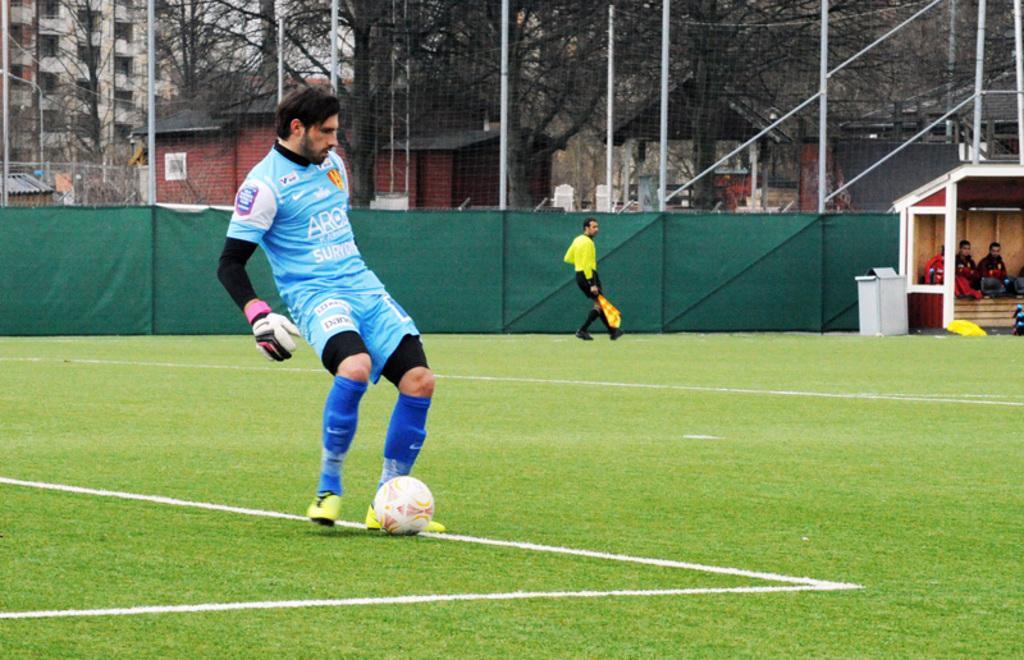In one or two sentences, can you explain what this image depicts? In this image I can see an open grass ground and on it I can see two persons are standing. I can see both of them are wearing sports jerseys, shoes and in the front I can see one man is wearing a glove. I can also see a white colour football near his legs. In the background I can see one man is holding a flag. In the background I can also see number of trees, green colour clothes, number of buildings and number of poles. On the right side of the image I can see a box, a shack and in it I can see three persons. 